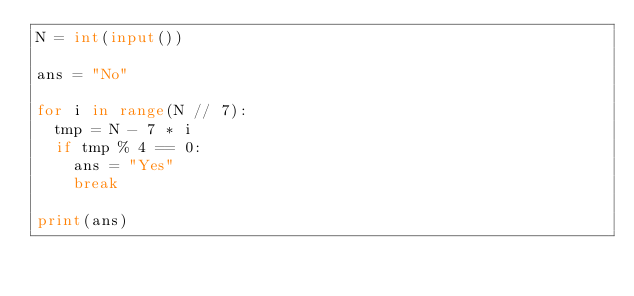Convert code to text. <code><loc_0><loc_0><loc_500><loc_500><_Python_>N = int(input())

ans = "No"

for i in range(N // 7):
  tmp = N - 7 * i
  if tmp % 4 == 0:
    ans = "Yes"
    break
    
print(ans)</code> 